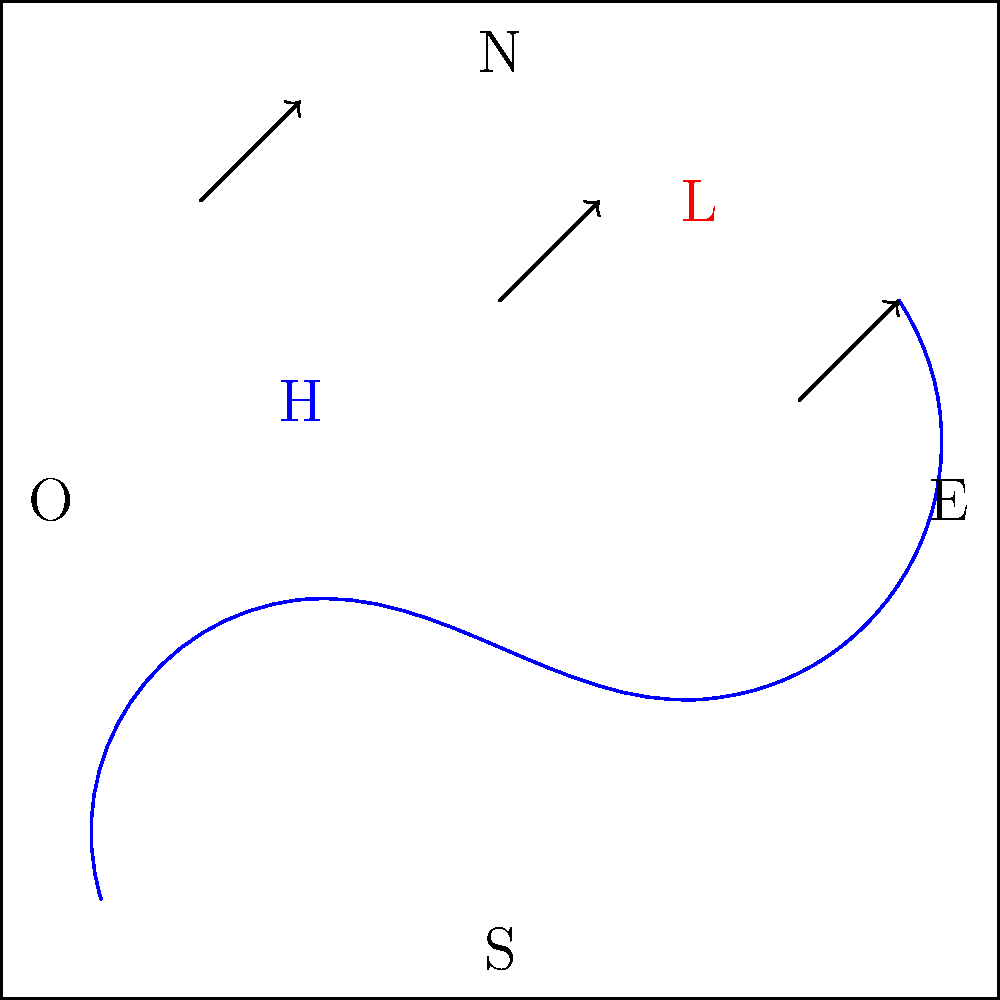Analizando el mapa meteorológico para una expedición de vela a lo largo de la costa argentina, ¿cuál es la dirección predominante del viento y cómo afectaría tu planificación de la ruta? Para responder a esta pregunta, debemos analizar el mapa meteorológico paso a paso:

1. Observamos las flechas de viento en el mapa. Todas apuntan en dirección noreste.

2. La dirección del viento es crucial para la navegación a vela. Un viento del suroeste (como se muestra) sería favorable para navegar hacia el noreste a lo largo de la costa argentina.

3. Notamos un sistema de alta presión (H) en el oeste y un sistema de baja presión (L) en el este. Esto confirma la dirección del viento, ya que el aire fluye de alta a baja presión en el hemisferio sur, girando en sentido horario alrededor de altas presiones y en sentido antihorario alrededor de bajas presiones.

4. La costa se extiende aproximadamente de suroeste a noreste, lo que significa que el viento sería principalmente paralelo a la costa.

5. Para planificar la ruta, consideraríamos:
   a) Navegar cerca de la costa para aprovechar el viento favorable.
   b) Utilizar técnicas de navegación como ceñida o través para maximizar la velocidad.
   c) Estar atentos a posibles cambios en la dirección del viento cerca de la costa debido a efectos locales.

6. También deberíamos considerar que el sistema de baja presión podría traer condiciones meteorológicas más inestables, por lo que sería prudente planificar refugios seguros a lo largo de la ruta.
Answer: Viento predominante del suroeste; planificar ruta cercana a la costa aprovechando vientos favorables. 